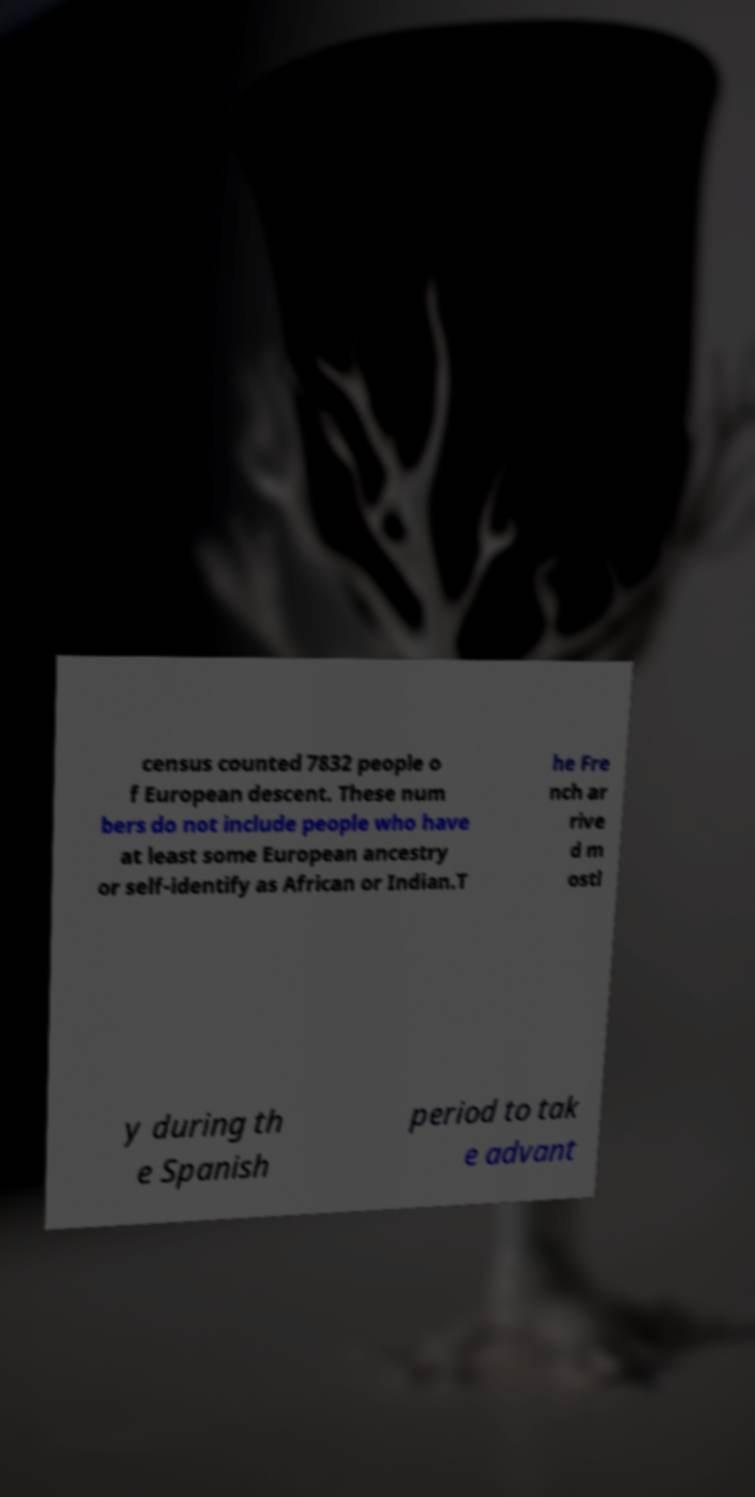Can you read and provide the text displayed in the image?This photo seems to have some interesting text. Can you extract and type it out for me? census counted 7832 people o f European descent. These num bers do not include people who have at least some European ancestry or self-identify as African or Indian.T he Fre nch ar rive d m ostl y during th e Spanish period to tak e advant 